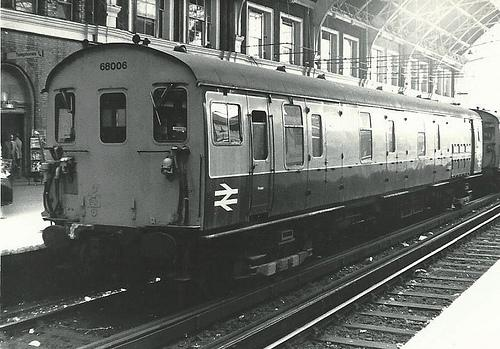Question: what is the transportation?
Choices:
A. A car.
B. A truck.
C. A van.
D. A train.
Answer with the letter. Answer: D Question: who is standing on the platform?
Choices:
A. The children.
B. People.
C. The dogs.
D. The conductor.
Answer with the letter. Answer: B Question: what is this destination?
Choices:
A. Chicago.
B. A train station.
C. An airport.
D. The bus stop.
Answer with the letter. Answer: B Question: what are the numbers?
Choices:
A. 68006.
B. 67890.
C. 3210.
D. 567432.
Answer with the letter. Answer: A Question: how many train window are opened?
Choices:
A. Two.
B. Three.
C. One.
D. Four.
Answer with the letter. Answer: C Question: what is 68006?
Choices:
A. The bus number.
B. The flight number.
C. The zip code.
D. The train number.
Answer with the letter. Answer: D 